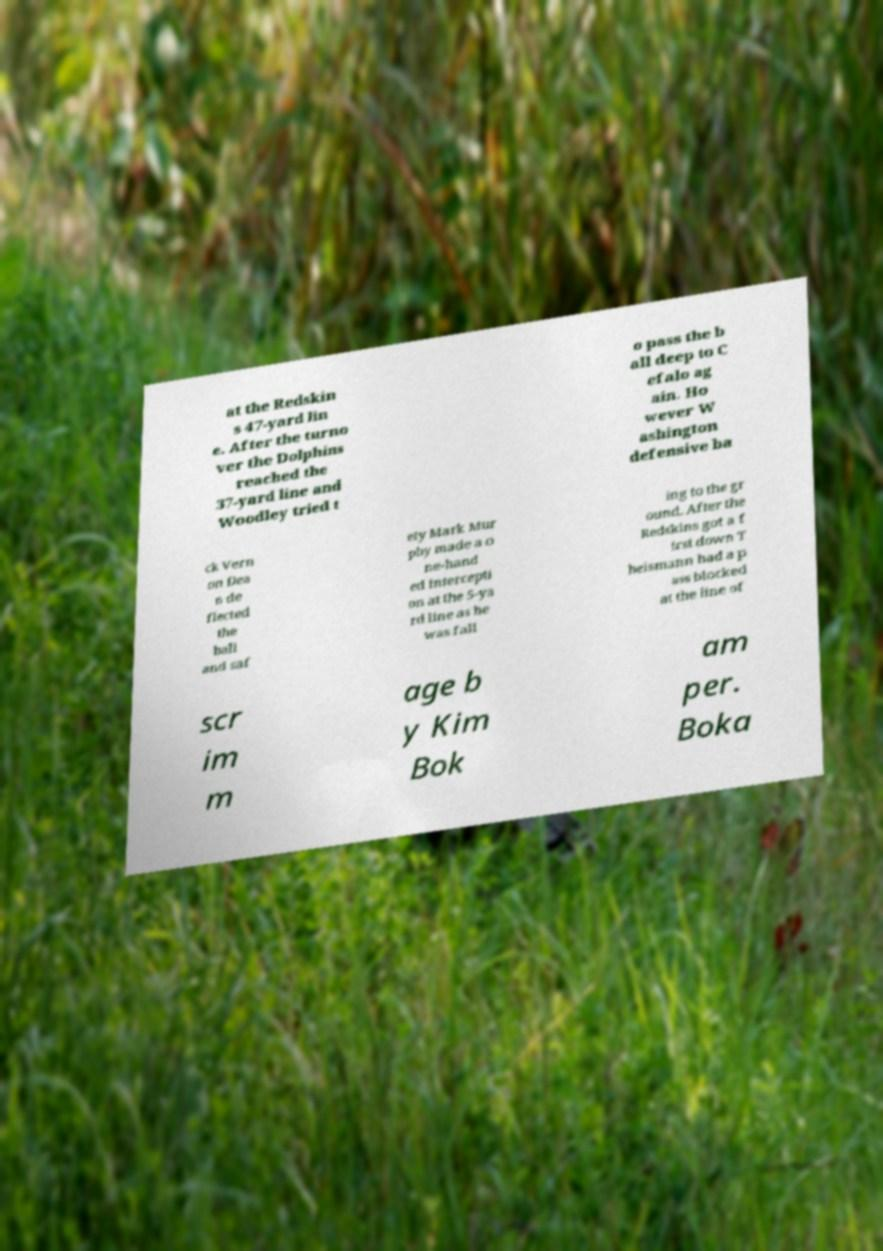Can you read and provide the text displayed in the image?This photo seems to have some interesting text. Can you extract and type it out for me? at the Redskin s 47-yard lin e. After the turno ver the Dolphins reached the 37-yard line and Woodley tried t o pass the b all deep to C efalo ag ain. Ho wever W ashington defensive ba ck Vern on Dea n de flected the ball and saf ety Mark Mur phy made a o ne-hand ed intercepti on at the 5-ya rd line as he was fall ing to the gr ound. After the Redskins got a f irst down T heismann had a p ass blocked at the line of scr im m age b y Kim Bok am per. Boka 